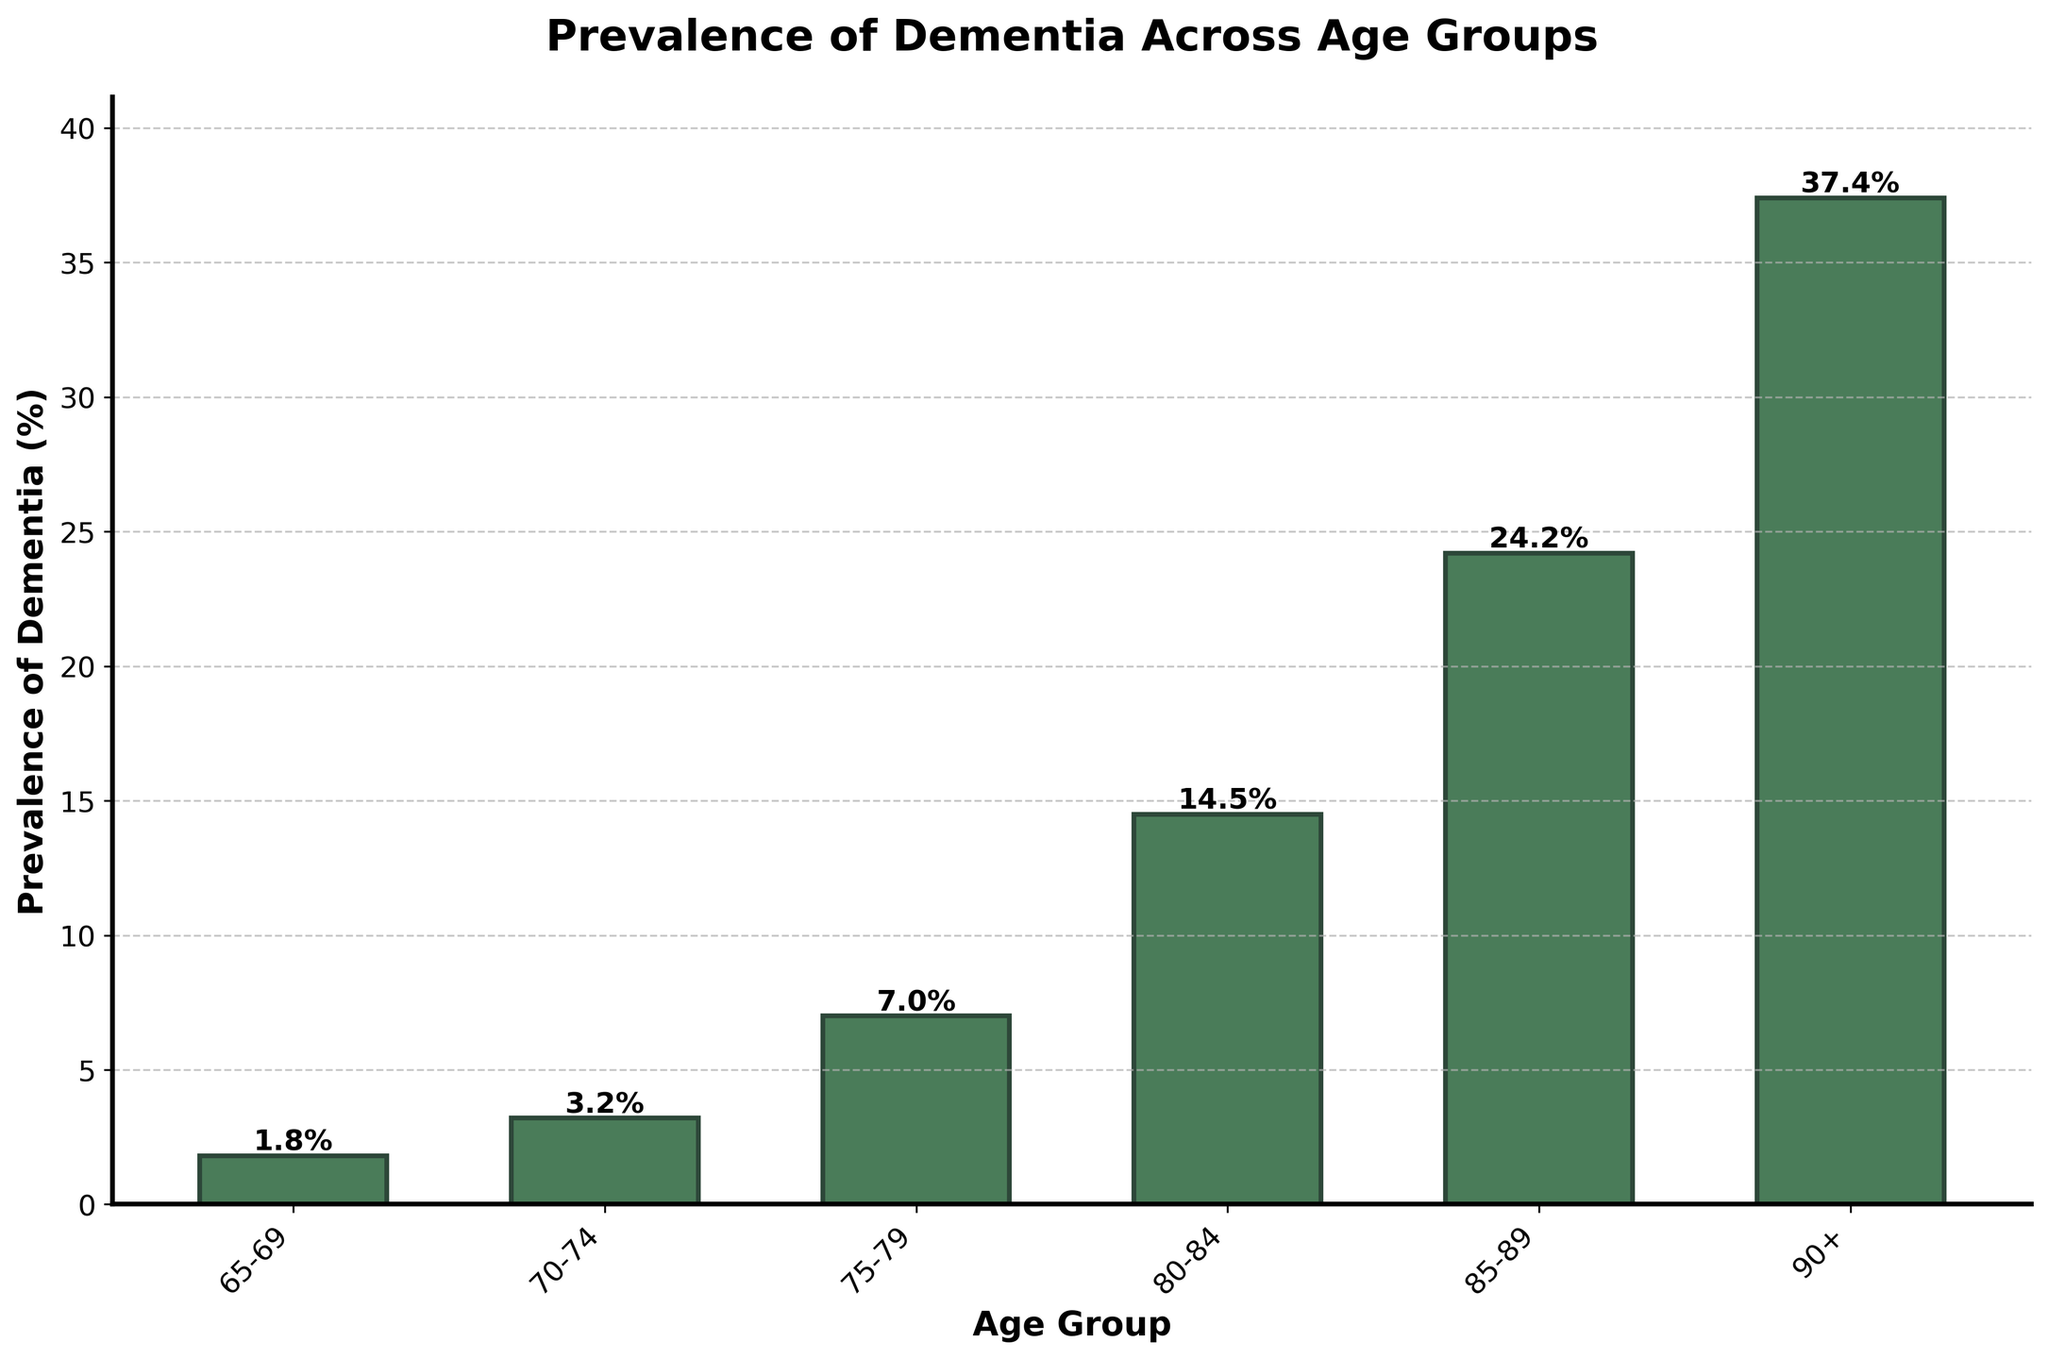What is the prevalence of dementia in the 70-74 age group? Look at the bar corresponding to the 70-74 age group on the x-axis and read its height or the labeled percentage.
Answer: 3.2% Which age group has the highest prevalence of dementia? Identify the tallest bar on the chart, which represents the age group with the highest prevalence percentage.
Answer: 90+ What is the difference in dementia prevalence between the 75-79 age group and the 85-89 age group? Subtract the prevalence percentage of the 75-79 age group from that of the 85-89 age group. 24.2% - 7.0% = 17.2%
Answer: 17.2% How does the prevalence of dementia change as people age from 65-69 to 80-84? Compare the heights of the bars for the age groups 65-69 and 80-84 and note the increase in percentage.
Answer: It increases from 1.8% to 14.5% Which two consecutive age groups show the largest increase in dementia prevalence? Calculate the difference in prevalence between consecutive age groups and identify the pair with the highest increase. The increase between 85-89 and 90+ is 37.4% - 24.2% = 13.2%, which is the largest.
Answer: 85-89 to 90+ What is the average prevalence of dementia across all listed age groups? Sum the prevalence percentages of all age groups (1.8 + 3.2 + 7.0 + 14.5 + 24.2 + 37.4) and divide by the number of age groups. (1.8 + 3.2 + 7.0 + 14.5 + 24.2 + 37.4) / 6 = 14.68%
Answer: 14.68% Is the prevalence of dementia for the 80-84 age group higher than the average prevalence across all age groups? Compare the prevalence of the 80-84 age group (14.5%) with the previously calculated average (14.68%).
Answer: No What trend can be observed from the prevalence of dementia across different age groups? By observing the heights of the bars from left to right, note the increasing pattern in prevalence as age increases.
Answer: Increasing trend How much more prevalent is dementia in the 90+ age group compared to the 65-69 age group? Subtract the prevalence percentage of the 65-69 age group from that of the 90+ age group. 37.4% - 1.8% = 35.6%
Answer: 35.6% What is the median prevalence of dementia across all age groups? List the prevalence percentages (1.8, 3.2, 7.0, 14.5, 24.2, 37.4) and find the middle value. Since there are six data points, the median is the average of the third and fourth values. (7.0 + 14.5) / 2 = 10.75
Answer: 10.75 